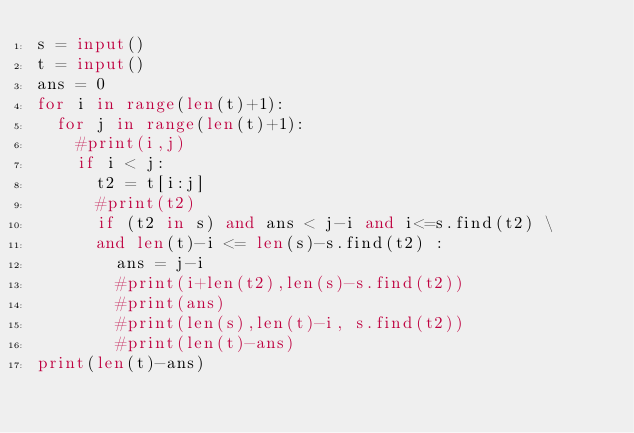<code> <loc_0><loc_0><loc_500><loc_500><_Python_>s = input()
t = input() 
ans = 0
for i in range(len(t)+1):
  for j in range(len(t)+1):
    #print(i,j)
    if i < j:
      t2 = t[i:j]
      #print(t2)
      if (t2 in s) and ans < j-i and i<=s.find(t2) \
      and len(t)-i <= len(s)-s.find(t2) :
        ans = j-i
        #print(i+len(t2),len(s)-s.find(t2))
        #print(ans)
        #print(len(s),len(t)-i, s.find(t2))
        #print(len(t)-ans)
print(len(t)-ans)</code> 